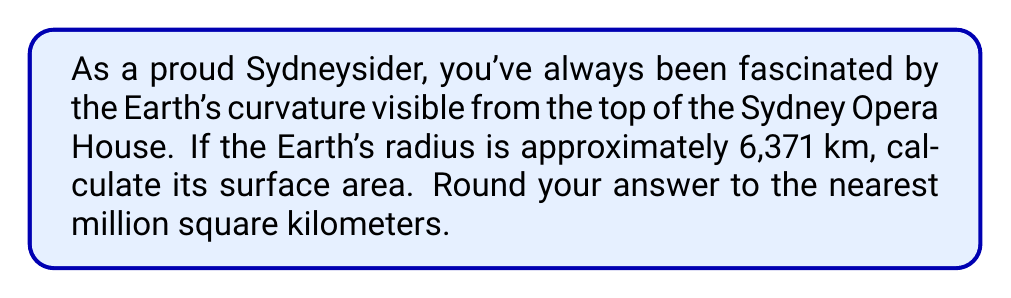Teach me how to tackle this problem. Let's approach this step-by-step:

1) The formula for the surface area of a sphere is:

   $$A = 4\pi r^2$$

   where $A$ is the surface area and $r$ is the radius.

2) We're given that the Earth's radius is 6,371 km. Let's substitute this into our formula:

   $$A = 4\pi (6,371)^2$$

3) Let's calculate this:
   
   $$A = 4 \times \pi \times 6,371^2$$
   $$A = 4 \times \pi \times 40,589,641$$
   $$A = 509,295,579.6... \text{ km}^2$$

4) Rounding to the nearest million square kilometers:

   $$A \approx 509,000,000 \text{ km}^2$$
Answer: $509,000,000 \text{ km}^2$ 